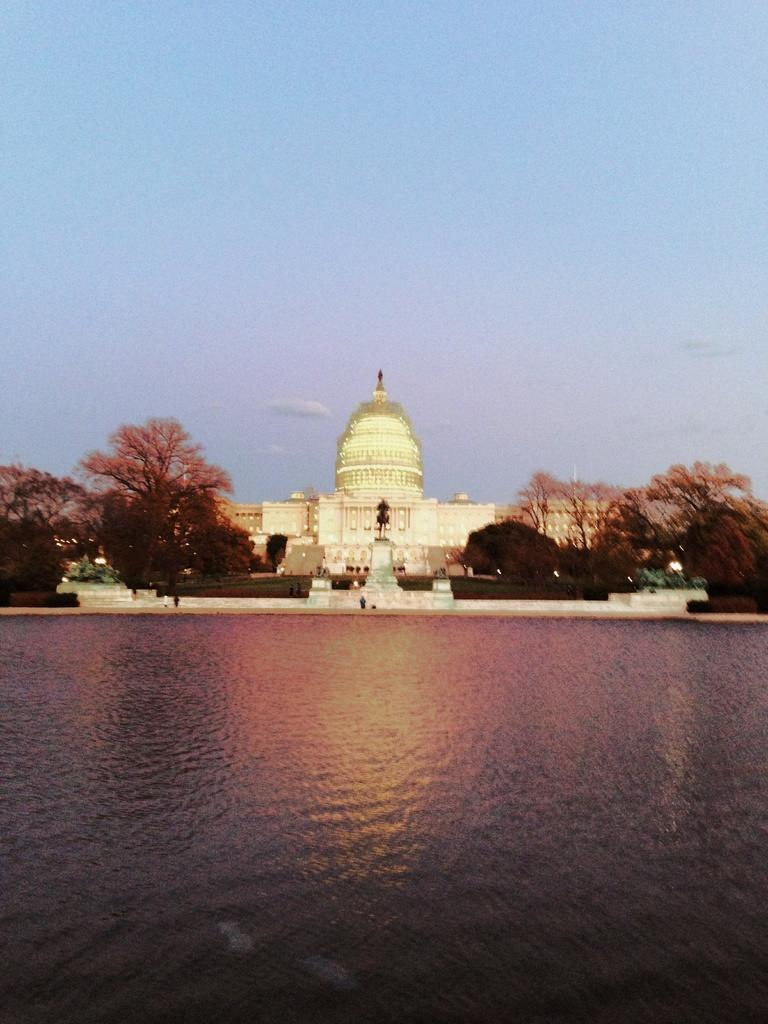What is the primary element visible in the image? There is water in the image. What can be seen in the center of the image? There is a statue in the center of the image. What type of natural elements are visible in the background of the image? There are trees in the background of the image. What type of man-made structures can be seen in the background of the image? There are buildings in the background of the image. What part of the natural environment is visible in the background of the image? The sky is visible in the background of the image. What type of dress is the statue wearing in the image? The statue is not wearing a dress; it is a statue and does not have clothing. 